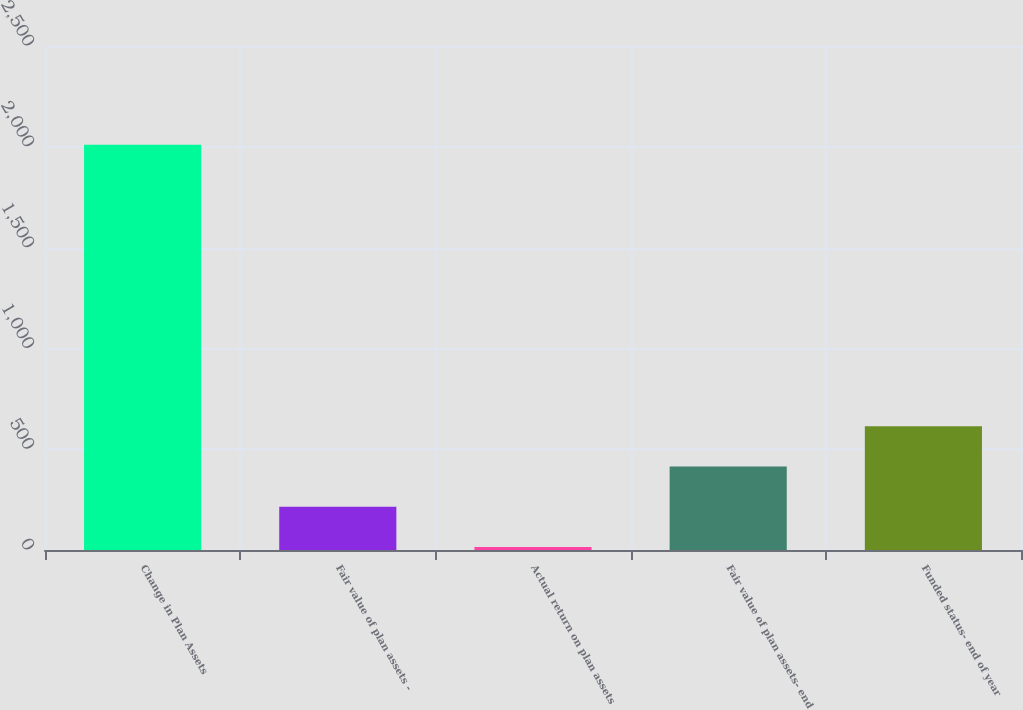Convert chart. <chart><loc_0><loc_0><loc_500><loc_500><bar_chart><fcel>Change in Plan Assets<fcel>Fair value of plan assets -<fcel>Actual return on plan assets<fcel>Fair value of plan assets- end<fcel>Funded status- end of year<nl><fcel>2010<fcel>214.5<fcel>15<fcel>414<fcel>613.5<nl></chart> 